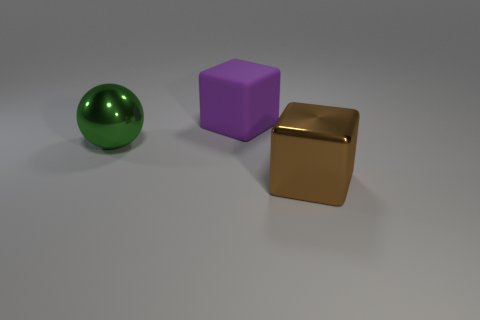Add 3 purple things. How many objects exist? 6 Subtract all balls. How many objects are left? 2 Subtract all big yellow cylinders. Subtract all big brown blocks. How many objects are left? 2 Add 1 brown metallic objects. How many brown metallic objects are left? 2 Add 1 big blue matte cylinders. How many big blue matte cylinders exist? 1 Subtract 0 yellow cubes. How many objects are left? 3 